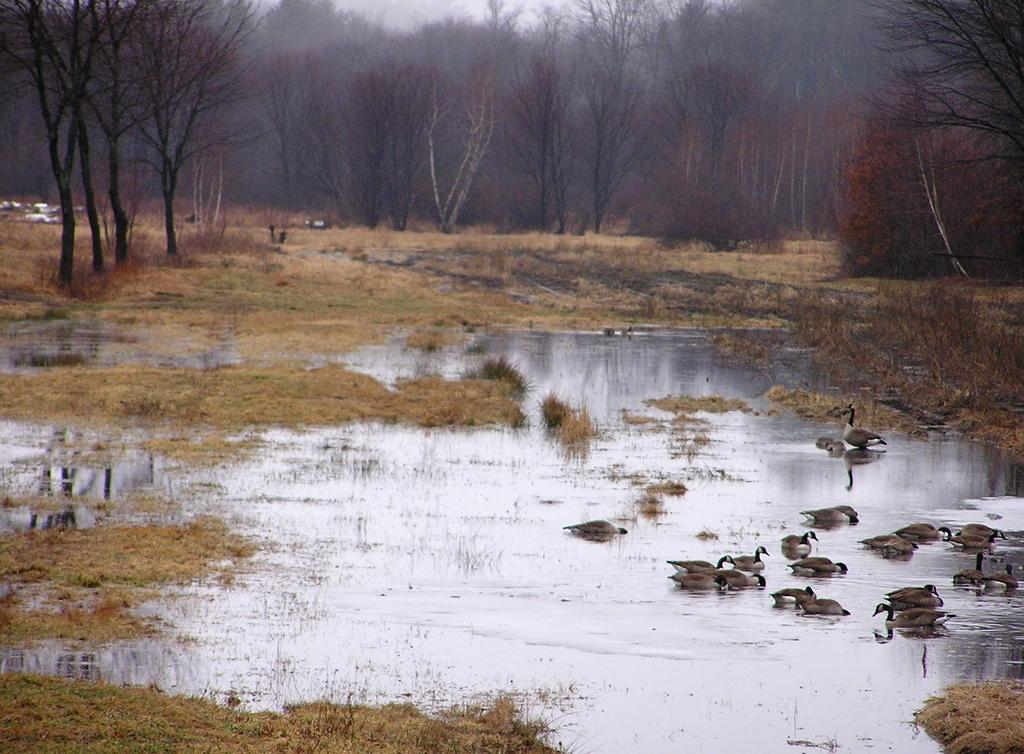What type of animals can be seen on the surface of the water in the image? There are birds on the surface of the water in the image. What type of vegetation is visible in the image? There is grass visible in the image, and there are also trees. What part of the natural environment is visible in the image? The sky is visible in the image. What type of pain can be seen in the image? There is no pain present in the image; it features birds on the water, grass, trees, and the sky. What type of cushion is used by the birds to rest on the water? There is no cushion present in the image; the birds are resting on the water's surface. 